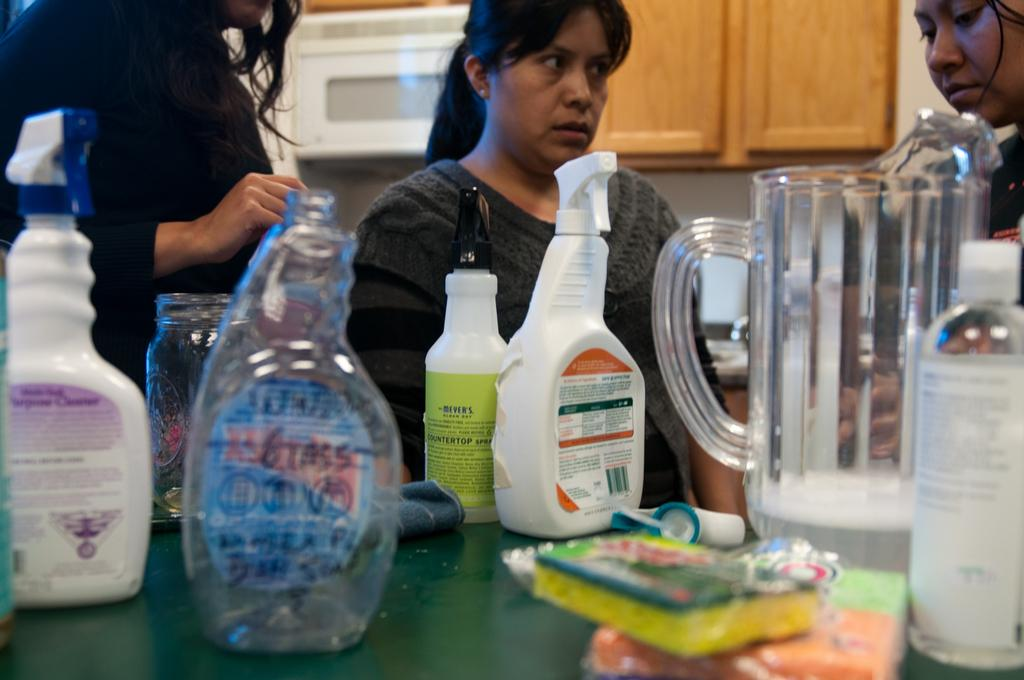How many people are in the image? There is a group of people standing in the image. Where are the people standing? The people are standing on the floor. What is present on the table in the image? There is a table in the image, and there is a jar on the table. Are there any other objects on the table? Yes, there are objects on the table. What type of notebook is being used by the people in the image? There is no notebook present in the image. Can you tell me how the people's hearts are beating in the image? There is no information about the people's hearts in the image. 